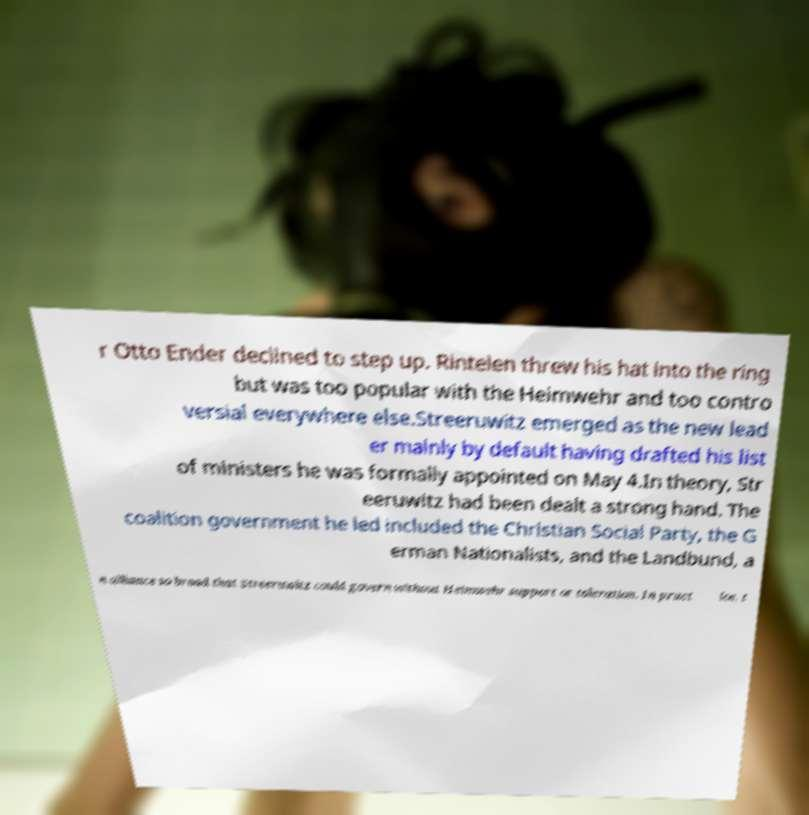I need the written content from this picture converted into text. Can you do that? r Otto Ender declined to step up. Rintelen threw his hat into the ring but was too popular with the Heimwehr and too contro versial everywhere else.Streeruwitz emerged as the new lead er mainly by default having drafted his list of ministers he was formally appointed on May 4.In theory, Str eeruwitz had been dealt a strong hand. The coalition government he led included the Christian Social Party, the G erman Nationalists, and the Landbund, a n alliance so broad that Streeruwitz could govern without Heimwehr support or toleration. In pract ice, t 